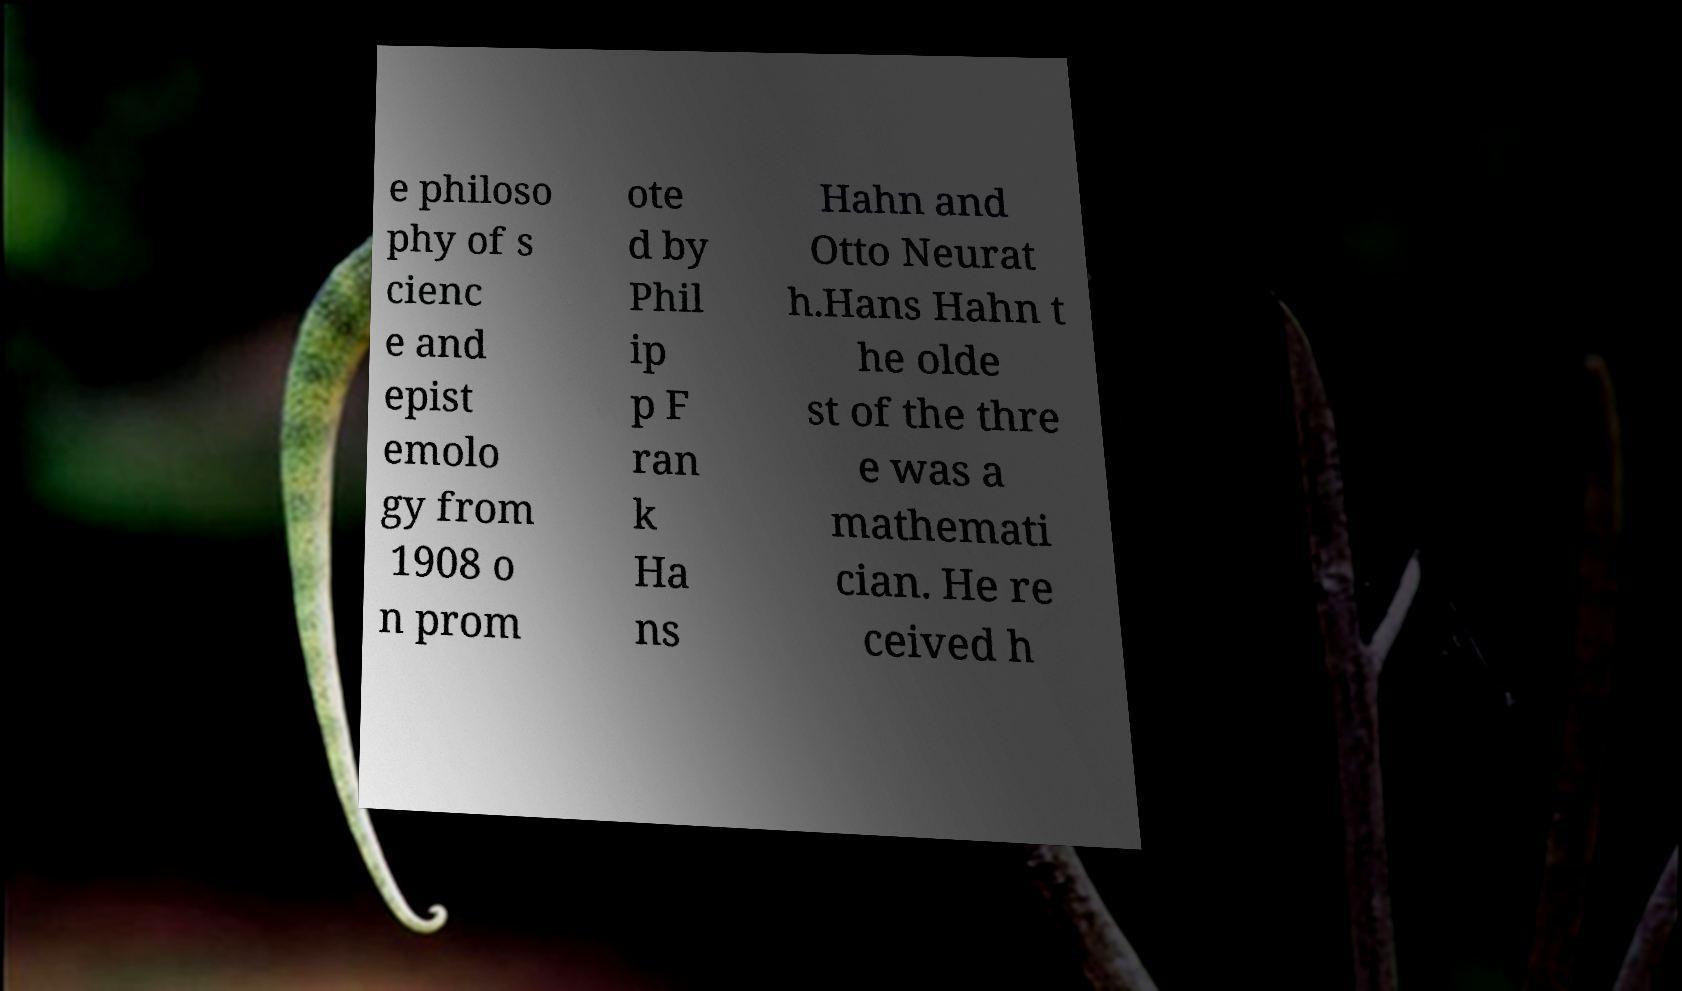Please identify and transcribe the text found in this image. e philoso phy of s cienc e and epist emolo gy from 1908 o n prom ote d by Phil ip p F ran k Ha ns Hahn and Otto Neurat h.Hans Hahn t he olde st of the thre e was a mathemati cian. He re ceived h 